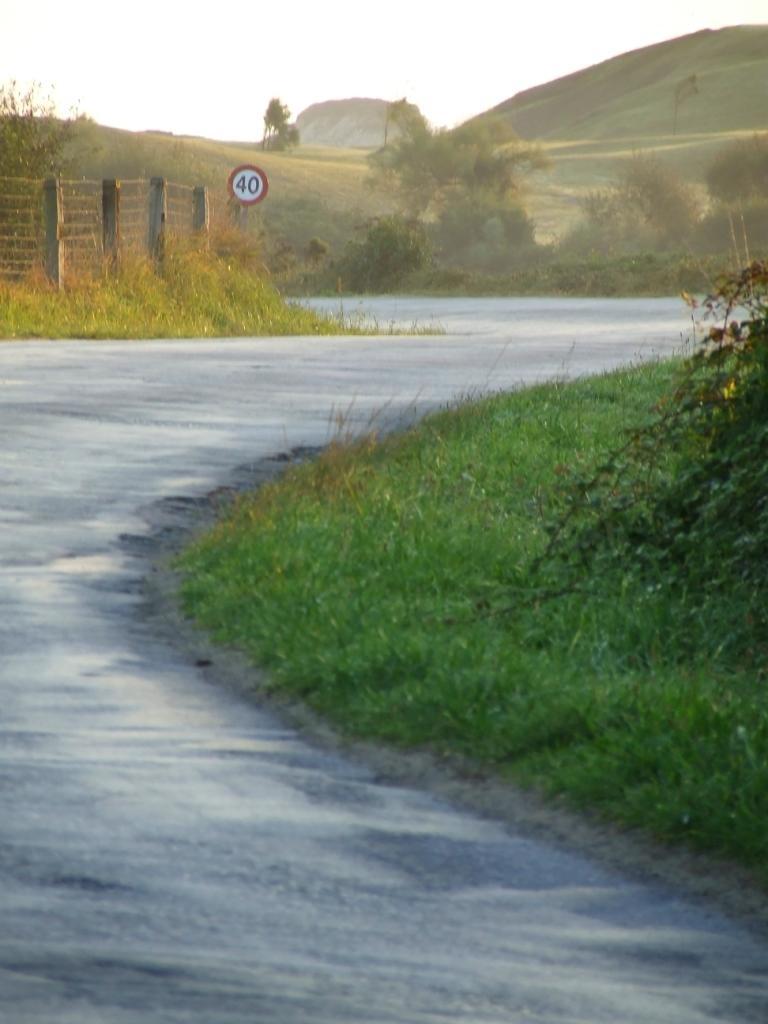Could you give a brief overview of what you see in this image? In this image we can see a road. On the right side of the image, we can see grass and plants. In the background, we can see boundary wall, sign board, grass, plants and mountain. At the top of the image, we can see the sky. 